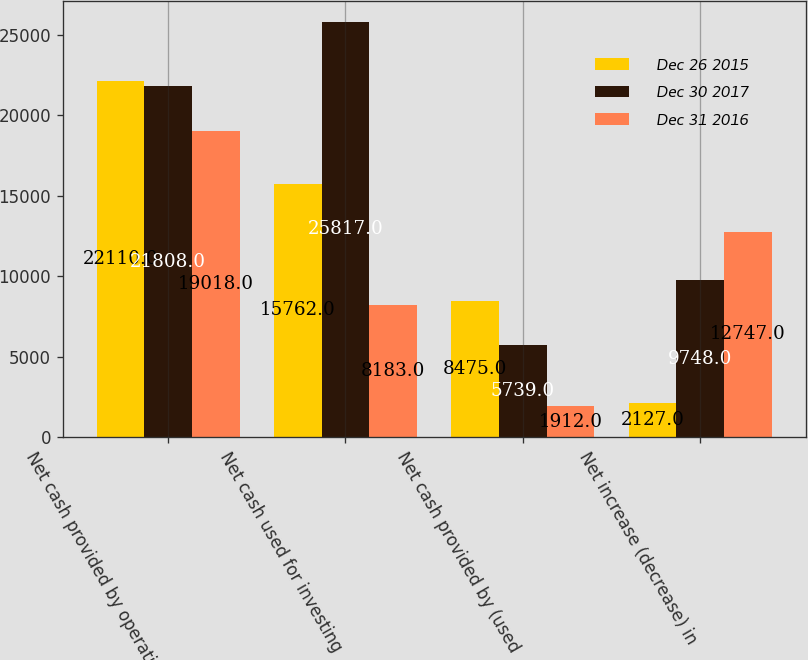<chart> <loc_0><loc_0><loc_500><loc_500><stacked_bar_chart><ecel><fcel>Net cash provided by operating<fcel>Net cash used for investing<fcel>Net cash provided by (used<fcel>Net increase (decrease) in<nl><fcel>Dec 26 2015<fcel>22110<fcel>15762<fcel>8475<fcel>2127<nl><fcel>Dec 30 2017<fcel>21808<fcel>25817<fcel>5739<fcel>9748<nl><fcel>Dec 31 2016<fcel>19018<fcel>8183<fcel>1912<fcel>12747<nl></chart> 